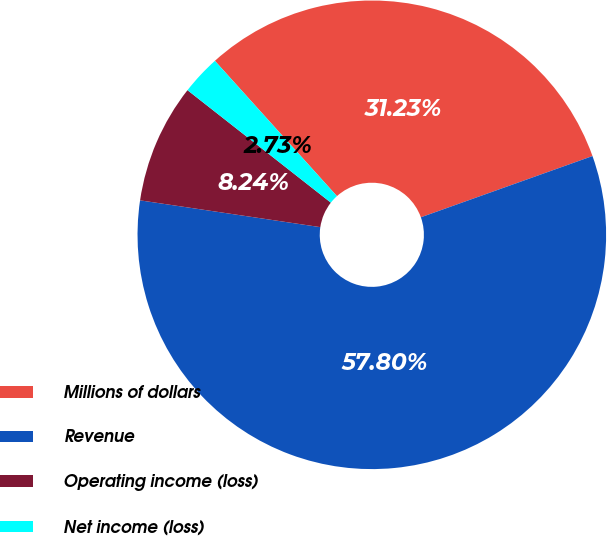Convert chart to OTSL. <chart><loc_0><loc_0><loc_500><loc_500><pie_chart><fcel>Millions of dollars<fcel>Revenue<fcel>Operating income (loss)<fcel>Net income (loss)<nl><fcel>31.23%<fcel>57.81%<fcel>8.24%<fcel>2.73%<nl></chart> 